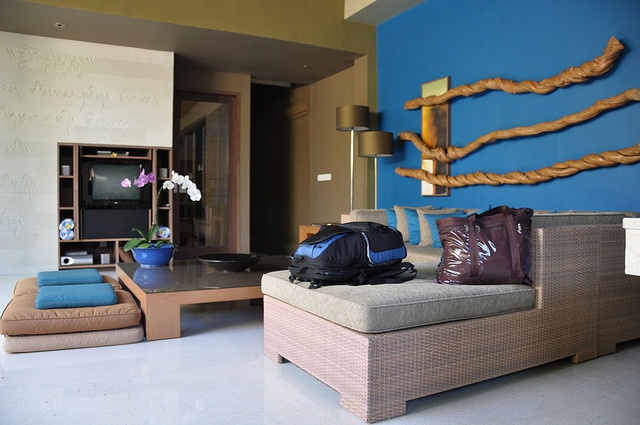Describe the objects in this image and their specific colors. I can see couch in gray, lightgray, darkgray, and black tones, dining table in gray, tan, and black tones, backpack in gray, black, navy, and blue tones, handbag in gray, black, and purple tones, and tv in gray, black, purple, and violet tones in this image. 